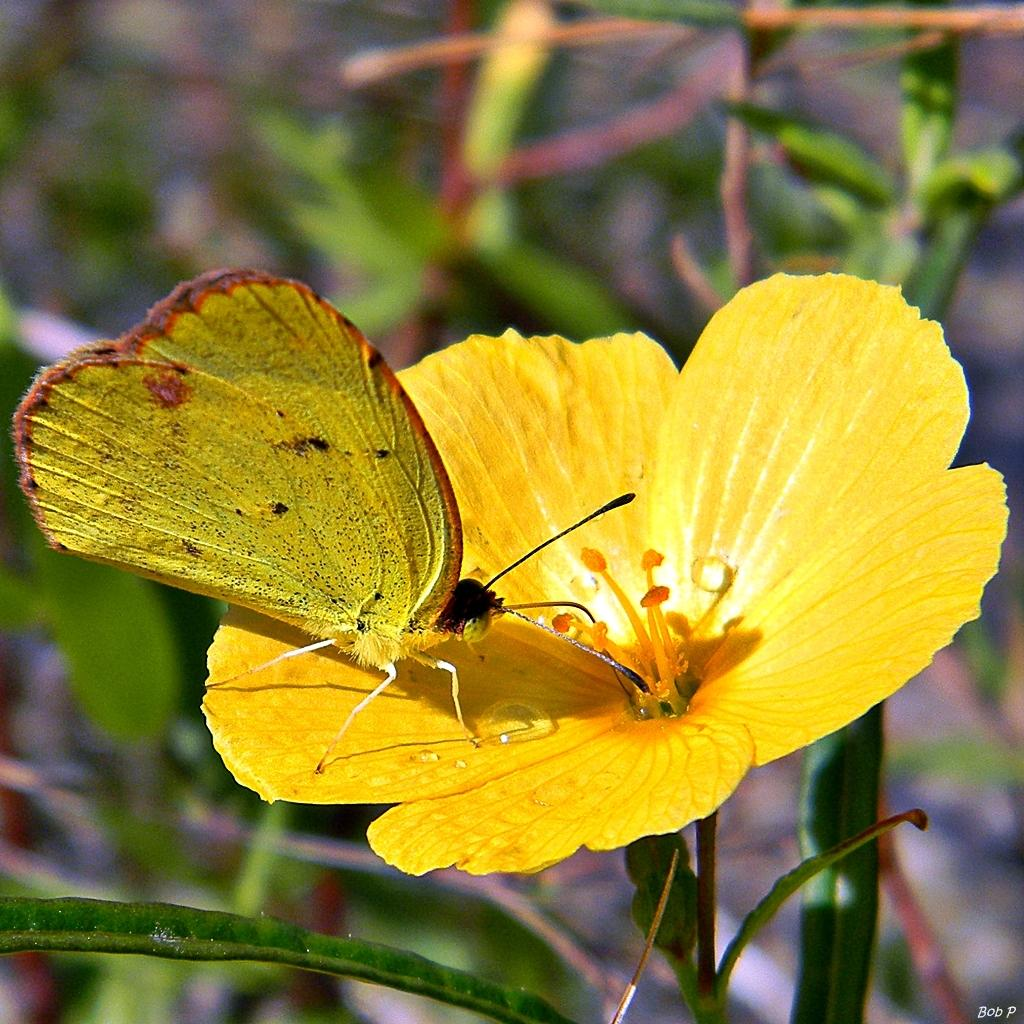What is the main subject of the image? There is a butterfly in the image. Where is the butterfly located? The butterfly is on a flower. What can be seen behind the flower? There is a group of plants visible behind the flower. What type of jar is the butterfly using to collect nectar from the flower? There is no jar present in the image; the butterfly is directly on the flower. 